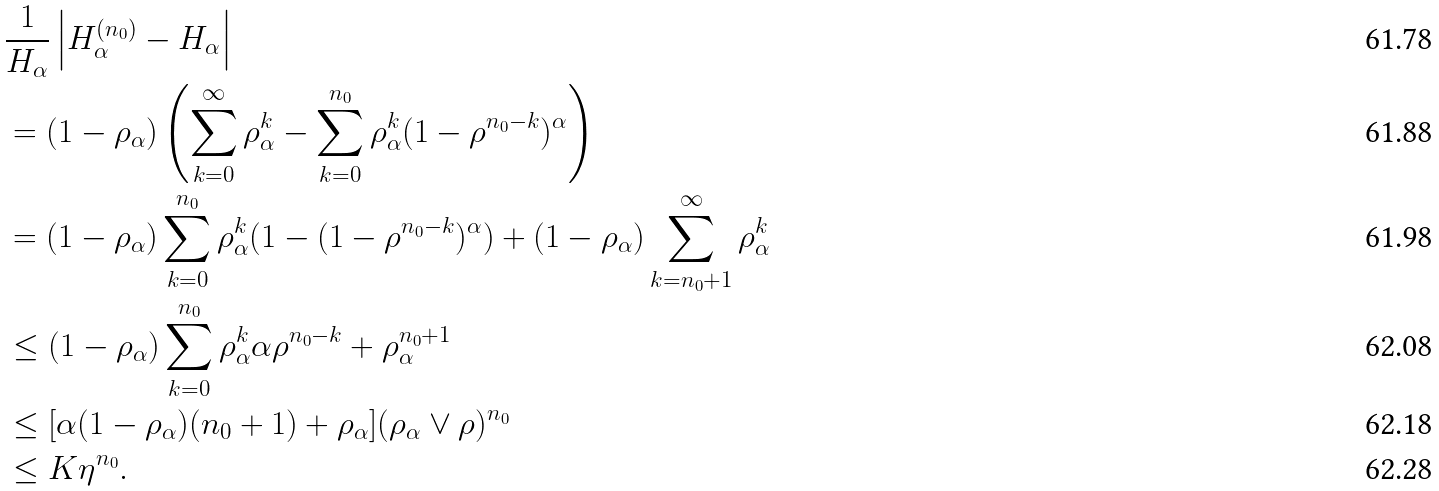Convert formula to latex. <formula><loc_0><loc_0><loc_500><loc_500>& \frac { 1 } { H _ { \alpha } } \left | H _ { \alpha } ^ { ( n _ { 0 } ) } - H _ { \alpha } \right | \\ & = ( 1 - \rho _ { \alpha } ) \left ( \sum _ { k = 0 } ^ { \infty } \rho _ { \alpha } ^ { k } - \sum _ { k = 0 } ^ { n _ { 0 } } \rho _ { \alpha } ^ { k } ( 1 - \rho ^ { n _ { 0 } - k } ) ^ { \alpha } \right ) \\ & = ( 1 - \rho _ { \alpha } ) \sum _ { k = 0 } ^ { n _ { 0 } } \rho _ { \alpha } ^ { k } ( 1 - ( 1 - \rho ^ { n _ { 0 } - k } ) ^ { \alpha } ) + ( 1 - \rho _ { \alpha } ) \sum _ { k = n _ { 0 } + 1 } ^ { \infty } \rho _ { \alpha } ^ { k } \\ & \leq ( 1 - \rho _ { \alpha } ) \sum _ { k = 0 } ^ { n _ { 0 } } \rho _ { \alpha } ^ { k } \alpha \rho ^ { n _ { 0 } - k } + \rho _ { \alpha } ^ { n _ { 0 } + 1 } \\ & \leq [ \alpha ( 1 - \rho _ { \alpha } ) ( n _ { 0 } + 1 ) + \rho _ { \alpha } ] ( \rho _ { \alpha } \vee \rho ) ^ { n _ { 0 } } \\ & \leq K \eta ^ { n _ { 0 } } .</formula> 